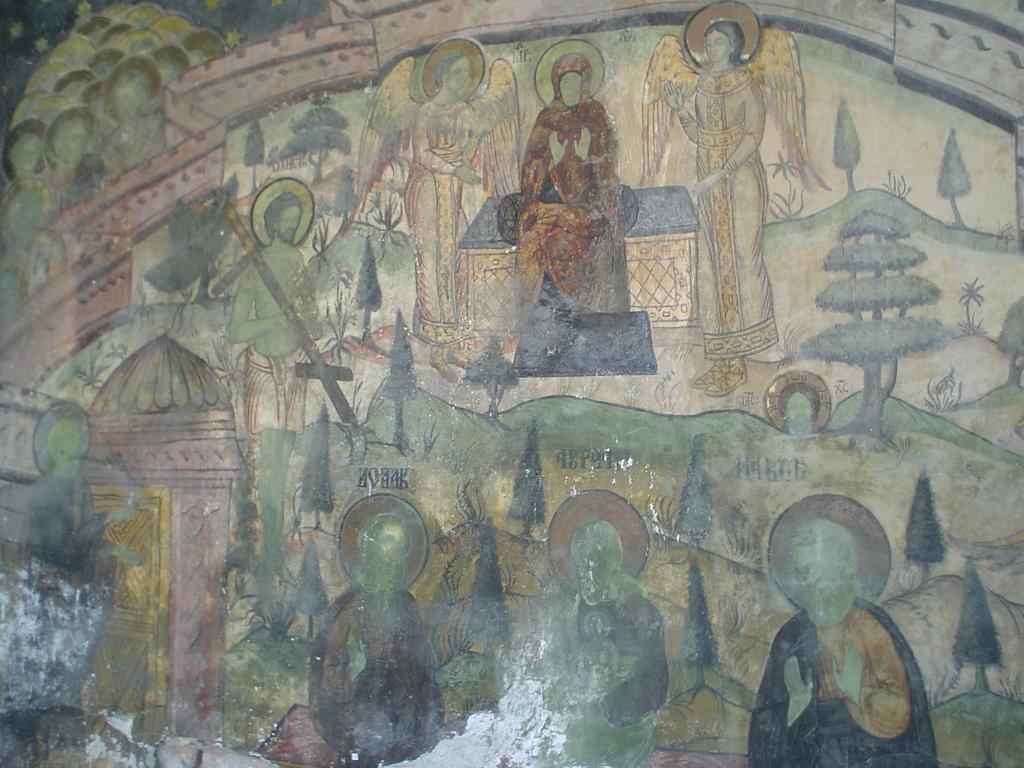How would you summarize this image in a sentence or two? In this image we can see a paining, which consists of people, trees, plants, houses and a few other objects on it. 